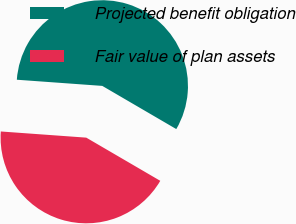Convert chart to OTSL. <chart><loc_0><loc_0><loc_500><loc_500><pie_chart><fcel>Projected benefit obligation<fcel>Fair value of plan assets<nl><fcel>57.26%<fcel>42.74%<nl></chart> 